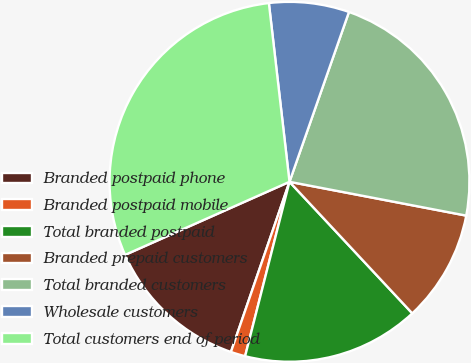Convert chart. <chart><loc_0><loc_0><loc_500><loc_500><pie_chart><fcel>Branded postpaid phone<fcel>Branded postpaid mobile<fcel>Total branded postpaid<fcel>Branded prepaid customers<fcel>Total branded customers<fcel>Wholesale customers<fcel>Total customers end of period<nl><fcel>13.07%<fcel>1.31%<fcel>15.92%<fcel>10.04%<fcel>22.65%<fcel>7.19%<fcel>29.83%<nl></chart> 